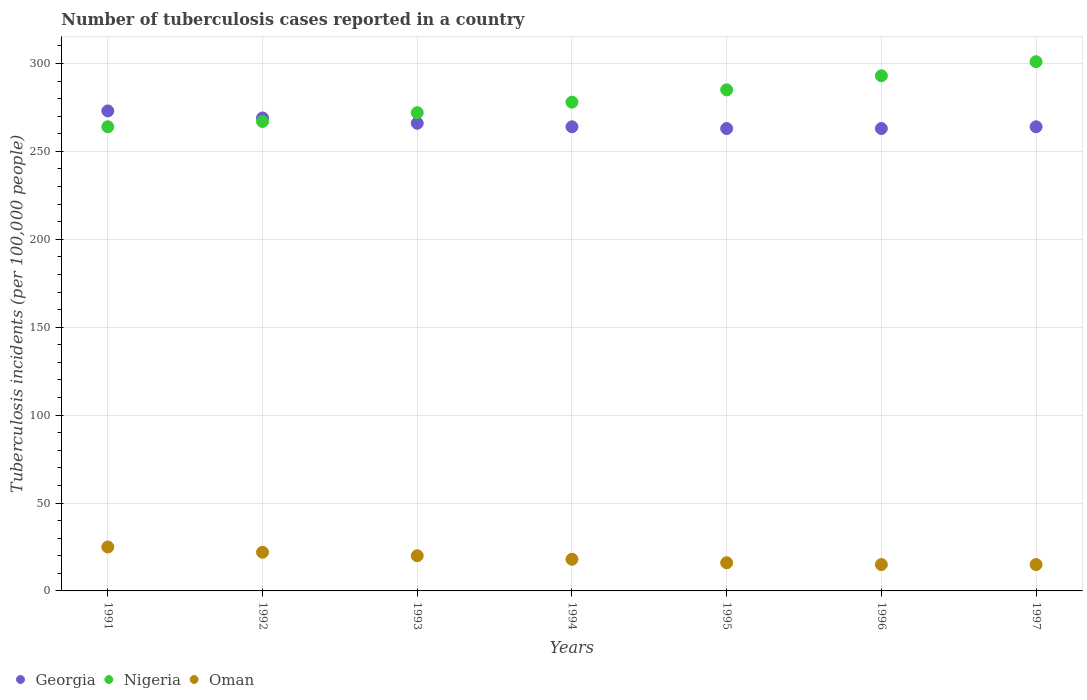How many different coloured dotlines are there?
Your answer should be very brief. 3. Is the number of dotlines equal to the number of legend labels?
Ensure brevity in your answer.  Yes. What is the number of tuberculosis cases reported in in Nigeria in 1996?
Your answer should be very brief. 293. Across all years, what is the maximum number of tuberculosis cases reported in in Georgia?
Provide a short and direct response. 273. Across all years, what is the minimum number of tuberculosis cases reported in in Nigeria?
Provide a short and direct response. 264. In which year was the number of tuberculosis cases reported in in Nigeria maximum?
Give a very brief answer. 1997. In which year was the number of tuberculosis cases reported in in Georgia minimum?
Make the answer very short. 1995. What is the total number of tuberculosis cases reported in in Georgia in the graph?
Provide a succinct answer. 1862. What is the difference between the number of tuberculosis cases reported in in Nigeria in 1994 and that in 1997?
Your answer should be compact. -23. What is the difference between the number of tuberculosis cases reported in in Oman in 1994 and the number of tuberculosis cases reported in in Nigeria in 1997?
Make the answer very short. -283. What is the average number of tuberculosis cases reported in in Nigeria per year?
Your answer should be compact. 280. In the year 1992, what is the difference between the number of tuberculosis cases reported in in Oman and number of tuberculosis cases reported in in Georgia?
Provide a succinct answer. -247. What is the ratio of the number of tuberculosis cases reported in in Nigeria in 1991 to that in 1993?
Give a very brief answer. 0.97. What is the difference between the highest and the lowest number of tuberculosis cases reported in in Oman?
Offer a terse response. 10. In how many years, is the number of tuberculosis cases reported in in Oman greater than the average number of tuberculosis cases reported in in Oman taken over all years?
Provide a succinct answer. 3. Is the sum of the number of tuberculosis cases reported in in Nigeria in 1993 and 1995 greater than the maximum number of tuberculosis cases reported in in Oman across all years?
Give a very brief answer. Yes. Does the number of tuberculosis cases reported in in Nigeria monotonically increase over the years?
Your answer should be compact. Yes. Is the number of tuberculosis cases reported in in Nigeria strictly greater than the number of tuberculosis cases reported in in Oman over the years?
Your answer should be very brief. Yes. How many dotlines are there?
Your response must be concise. 3. Does the graph contain any zero values?
Offer a terse response. No. Does the graph contain grids?
Keep it short and to the point. Yes. Where does the legend appear in the graph?
Offer a very short reply. Bottom left. How many legend labels are there?
Give a very brief answer. 3. What is the title of the graph?
Keep it short and to the point. Number of tuberculosis cases reported in a country. Does "Niger" appear as one of the legend labels in the graph?
Your answer should be compact. No. What is the label or title of the X-axis?
Offer a very short reply. Years. What is the label or title of the Y-axis?
Ensure brevity in your answer.  Tuberculosis incidents (per 100,0 people). What is the Tuberculosis incidents (per 100,000 people) of Georgia in 1991?
Offer a very short reply. 273. What is the Tuberculosis incidents (per 100,000 people) in Nigeria in 1991?
Your response must be concise. 264. What is the Tuberculosis incidents (per 100,000 people) of Oman in 1991?
Ensure brevity in your answer.  25. What is the Tuberculosis incidents (per 100,000 people) in Georgia in 1992?
Give a very brief answer. 269. What is the Tuberculosis incidents (per 100,000 people) in Nigeria in 1992?
Offer a very short reply. 267. What is the Tuberculosis incidents (per 100,000 people) in Oman in 1992?
Ensure brevity in your answer.  22. What is the Tuberculosis incidents (per 100,000 people) in Georgia in 1993?
Ensure brevity in your answer.  266. What is the Tuberculosis incidents (per 100,000 people) of Nigeria in 1993?
Provide a succinct answer. 272. What is the Tuberculosis incidents (per 100,000 people) of Georgia in 1994?
Your response must be concise. 264. What is the Tuberculosis incidents (per 100,000 people) in Nigeria in 1994?
Offer a very short reply. 278. What is the Tuberculosis incidents (per 100,000 people) of Georgia in 1995?
Your answer should be compact. 263. What is the Tuberculosis incidents (per 100,000 people) of Nigeria in 1995?
Offer a terse response. 285. What is the Tuberculosis incidents (per 100,000 people) in Georgia in 1996?
Make the answer very short. 263. What is the Tuberculosis incidents (per 100,000 people) in Nigeria in 1996?
Keep it short and to the point. 293. What is the Tuberculosis incidents (per 100,000 people) in Oman in 1996?
Your response must be concise. 15. What is the Tuberculosis incidents (per 100,000 people) in Georgia in 1997?
Keep it short and to the point. 264. What is the Tuberculosis incidents (per 100,000 people) in Nigeria in 1997?
Ensure brevity in your answer.  301. Across all years, what is the maximum Tuberculosis incidents (per 100,000 people) of Georgia?
Your answer should be very brief. 273. Across all years, what is the maximum Tuberculosis incidents (per 100,000 people) in Nigeria?
Ensure brevity in your answer.  301. Across all years, what is the maximum Tuberculosis incidents (per 100,000 people) of Oman?
Your response must be concise. 25. Across all years, what is the minimum Tuberculosis incidents (per 100,000 people) of Georgia?
Your answer should be compact. 263. Across all years, what is the minimum Tuberculosis incidents (per 100,000 people) of Nigeria?
Make the answer very short. 264. Across all years, what is the minimum Tuberculosis incidents (per 100,000 people) of Oman?
Provide a succinct answer. 15. What is the total Tuberculosis incidents (per 100,000 people) in Georgia in the graph?
Give a very brief answer. 1862. What is the total Tuberculosis incidents (per 100,000 people) of Nigeria in the graph?
Make the answer very short. 1960. What is the total Tuberculosis incidents (per 100,000 people) in Oman in the graph?
Give a very brief answer. 131. What is the difference between the Tuberculosis incidents (per 100,000 people) of Georgia in 1991 and that in 1992?
Give a very brief answer. 4. What is the difference between the Tuberculosis incidents (per 100,000 people) in Nigeria in 1991 and that in 1992?
Offer a terse response. -3. What is the difference between the Tuberculosis incidents (per 100,000 people) of Oman in 1991 and that in 1992?
Make the answer very short. 3. What is the difference between the Tuberculosis incidents (per 100,000 people) of Georgia in 1991 and that in 1993?
Provide a short and direct response. 7. What is the difference between the Tuberculosis incidents (per 100,000 people) in Oman in 1991 and that in 1993?
Offer a very short reply. 5. What is the difference between the Tuberculosis incidents (per 100,000 people) of Oman in 1991 and that in 1994?
Make the answer very short. 7. What is the difference between the Tuberculosis incidents (per 100,000 people) of Georgia in 1991 and that in 1996?
Provide a succinct answer. 10. What is the difference between the Tuberculosis incidents (per 100,000 people) of Nigeria in 1991 and that in 1996?
Ensure brevity in your answer.  -29. What is the difference between the Tuberculosis incidents (per 100,000 people) of Georgia in 1991 and that in 1997?
Offer a terse response. 9. What is the difference between the Tuberculosis incidents (per 100,000 people) of Nigeria in 1991 and that in 1997?
Your response must be concise. -37. What is the difference between the Tuberculosis incidents (per 100,000 people) of Nigeria in 1992 and that in 1993?
Your answer should be very brief. -5. What is the difference between the Tuberculosis incidents (per 100,000 people) in Oman in 1992 and that in 1993?
Provide a short and direct response. 2. What is the difference between the Tuberculosis incidents (per 100,000 people) in Georgia in 1992 and that in 1994?
Provide a short and direct response. 5. What is the difference between the Tuberculosis incidents (per 100,000 people) of Nigeria in 1992 and that in 1994?
Keep it short and to the point. -11. What is the difference between the Tuberculosis incidents (per 100,000 people) in Oman in 1992 and that in 1994?
Ensure brevity in your answer.  4. What is the difference between the Tuberculosis incidents (per 100,000 people) in Nigeria in 1992 and that in 1995?
Give a very brief answer. -18. What is the difference between the Tuberculosis incidents (per 100,000 people) of Oman in 1992 and that in 1996?
Provide a short and direct response. 7. What is the difference between the Tuberculosis incidents (per 100,000 people) in Nigeria in 1992 and that in 1997?
Your response must be concise. -34. What is the difference between the Tuberculosis incidents (per 100,000 people) in Oman in 1992 and that in 1997?
Keep it short and to the point. 7. What is the difference between the Tuberculosis incidents (per 100,000 people) of Nigeria in 1993 and that in 1994?
Your response must be concise. -6. What is the difference between the Tuberculosis incidents (per 100,000 people) in Oman in 1993 and that in 1994?
Make the answer very short. 2. What is the difference between the Tuberculosis incidents (per 100,000 people) of Oman in 1993 and that in 1995?
Provide a short and direct response. 4. What is the difference between the Tuberculosis incidents (per 100,000 people) in Georgia in 1993 and that in 1996?
Your response must be concise. 3. What is the difference between the Tuberculosis incidents (per 100,000 people) of Nigeria in 1993 and that in 1996?
Keep it short and to the point. -21. What is the difference between the Tuberculosis incidents (per 100,000 people) of Oman in 1993 and that in 1996?
Keep it short and to the point. 5. What is the difference between the Tuberculosis incidents (per 100,000 people) of Georgia in 1993 and that in 1997?
Provide a succinct answer. 2. What is the difference between the Tuberculosis incidents (per 100,000 people) of Georgia in 1994 and that in 1995?
Keep it short and to the point. 1. What is the difference between the Tuberculosis incidents (per 100,000 people) in Nigeria in 1994 and that in 1995?
Provide a succinct answer. -7. What is the difference between the Tuberculosis incidents (per 100,000 people) in Georgia in 1994 and that in 1996?
Make the answer very short. 1. What is the difference between the Tuberculosis incidents (per 100,000 people) in Nigeria in 1994 and that in 1996?
Offer a very short reply. -15. What is the difference between the Tuberculosis incidents (per 100,000 people) in Georgia in 1994 and that in 1997?
Make the answer very short. 0. What is the difference between the Tuberculosis incidents (per 100,000 people) in Oman in 1994 and that in 1997?
Ensure brevity in your answer.  3. What is the difference between the Tuberculosis incidents (per 100,000 people) of Georgia in 1996 and that in 1997?
Make the answer very short. -1. What is the difference between the Tuberculosis incidents (per 100,000 people) of Georgia in 1991 and the Tuberculosis incidents (per 100,000 people) of Nigeria in 1992?
Your answer should be compact. 6. What is the difference between the Tuberculosis incidents (per 100,000 people) in Georgia in 1991 and the Tuberculosis incidents (per 100,000 people) in Oman in 1992?
Provide a succinct answer. 251. What is the difference between the Tuberculosis incidents (per 100,000 people) in Nigeria in 1991 and the Tuberculosis incidents (per 100,000 people) in Oman in 1992?
Your answer should be compact. 242. What is the difference between the Tuberculosis incidents (per 100,000 people) in Georgia in 1991 and the Tuberculosis incidents (per 100,000 people) in Nigeria in 1993?
Provide a succinct answer. 1. What is the difference between the Tuberculosis incidents (per 100,000 people) in Georgia in 1991 and the Tuberculosis incidents (per 100,000 people) in Oman in 1993?
Make the answer very short. 253. What is the difference between the Tuberculosis incidents (per 100,000 people) of Nigeria in 1991 and the Tuberculosis incidents (per 100,000 people) of Oman in 1993?
Your answer should be very brief. 244. What is the difference between the Tuberculosis incidents (per 100,000 people) of Georgia in 1991 and the Tuberculosis incidents (per 100,000 people) of Oman in 1994?
Offer a very short reply. 255. What is the difference between the Tuberculosis incidents (per 100,000 people) in Nigeria in 1991 and the Tuberculosis incidents (per 100,000 people) in Oman in 1994?
Keep it short and to the point. 246. What is the difference between the Tuberculosis incidents (per 100,000 people) in Georgia in 1991 and the Tuberculosis incidents (per 100,000 people) in Nigeria in 1995?
Keep it short and to the point. -12. What is the difference between the Tuberculosis incidents (per 100,000 people) in Georgia in 1991 and the Tuberculosis incidents (per 100,000 people) in Oman in 1995?
Offer a very short reply. 257. What is the difference between the Tuberculosis incidents (per 100,000 people) in Nigeria in 1991 and the Tuberculosis incidents (per 100,000 people) in Oman in 1995?
Offer a terse response. 248. What is the difference between the Tuberculosis incidents (per 100,000 people) in Georgia in 1991 and the Tuberculosis incidents (per 100,000 people) in Oman in 1996?
Your answer should be very brief. 258. What is the difference between the Tuberculosis incidents (per 100,000 people) in Nigeria in 1991 and the Tuberculosis incidents (per 100,000 people) in Oman in 1996?
Offer a very short reply. 249. What is the difference between the Tuberculosis incidents (per 100,000 people) of Georgia in 1991 and the Tuberculosis incidents (per 100,000 people) of Nigeria in 1997?
Give a very brief answer. -28. What is the difference between the Tuberculosis incidents (per 100,000 people) of Georgia in 1991 and the Tuberculosis incidents (per 100,000 people) of Oman in 1997?
Keep it short and to the point. 258. What is the difference between the Tuberculosis incidents (per 100,000 people) of Nigeria in 1991 and the Tuberculosis incidents (per 100,000 people) of Oman in 1997?
Make the answer very short. 249. What is the difference between the Tuberculosis incidents (per 100,000 people) in Georgia in 1992 and the Tuberculosis incidents (per 100,000 people) in Oman in 1993?
Provide a short and direct response. 249. What is the difference between the Tuberculosis incidents (per 100,000 people) of Nigeria in 1992 and the Tuberculosis incidents (per 100,000 people) of Oman in 1993?
Make the answer very short. 247. What is the difference between the Tuberculosis incidents (per 100,000 people) in Georgia in 1992 and the Tuberculosis incidents (per 100,000 people) in Oman in 1994?
Ensure brevity in your answer.  251. What is the difference between the Tuberculosis incidents (per 100,000 people) of Nigeria in 1992 and the Tuberculosis incidents (per 100,000 people) of Oman in 1994?
Offer a terse response. 249. What is the difference between the Tuberculosis incidents (per 100,000 people) of Georgia in 1992 and the Tuberculosis incidents (per 100,000 people) of Nigeria in 1995?
Your response must be concise. -16. What is the difference between the Tuberculosis incidents (per 100,000 people) in Georgia in 1992 and the Tuberculosis incidents (per 100,000 people) in Oman in 1995?
Ensure brevity in your answer.  253. What is the difference between the Tuberculosis incidents (per 100,000 people) of Nigeria in 1992 and the Tuberculosis incidents (per 100,000 people) of Oman in 1995?
Offer a very short reply. 251. What is the difference between the Tuberculosis incidents (per 100,000 people) of Georgia in 1992 and the Tuberculosis incidents (per 100,000 people) of Oman in 1996?
Make the answer very short. 254. What is the difference between the Tuberculosis incidents (per 100,000 people) of Nigeria in 1992 and the Tuberculosis incidents (per 100,000 people) of Oman in 1996?
Provide a succinct answer. 252. What is the difference between the Tuberculosis incidents (per 100,000 people) of Georgia in 1992 and the Tuberculosis incidents (per 100,000 people) of Nigeria in 1997?
Give a very brief answer. -32. What is the difference between the Tuberculosis incidents (per 100,000 people) of Georgia in 1992 and the Tuberculosis incidents (per 100,000 people) of Oman in 1997?
Give a very brief answer. 254. What is the difference between the Tuberculosis incidents (per 100,000 people) in Nigeria in 1992 and the Tuberculosis incidents (per 100,000 people) in Oman in 1997?
Ensure brevity in your answer.  252. What is the difference between the Tuberculosis incidents (per 100,000 people) of Georgia in 1993 and the Tuberculosis incidents (per 100,000 people) of Oman in 1994?
Provide a succinct answer. 248. What is the difference between the Tuberculosis incidents (per 100,000 people) of Nigeria in 1993 and the Tuberculosis incidents (per 100,000 people) of Oman in 1994?
Provide a short and direct response. 254. What is the difference between the Tuberculosis incidents (per 100,000 people) in Georgia in 1993 and the Tuberculosis incidents (per 100,000 people) in Oman in 1995?
Make the answer very short. 250. What is the difference between the Tuberculosis incidents (per 100,000 people) in Nigeria in 1993 and the Tuberculosis incidents (per 100,000 people) in Oman in 1995?
Ensure brevity in your answer.  256. What is the difference between the Tuberculosis incidents (per 100,000 people) of Georgia in 1993 and the Tuberculosis incidents (per 100,000 people) of Oman in 1996?
Your answer should be compact. 251. What is the difference between the Tuberculosis incidents (per 100,000 people) in Nigeria in 1993 and the Tuberculosis incidents (per 100,000 people) in Oman in 1996?
Make the answer very short. 257. What is the difference between the Tuberculosis incidents (per 100,000 people) of Georgia in 1993 and the Tuberculosis incidents (per 100,000 people) of Nigeria in 1997?
Your answer should be compact. -35. What is the difference between the Tuberculosis incidents (per 100,000 people) of Georgia in 1993 and the Tuberculosis incidents (per 100,000 people) of Oman in 1997?
Provide a short and direct response. 251. What is the difference between the Tuberculosis incidents (per 100,000 people) of Nigeria in 1993 and the Tuberculosis incidents (per 100,000 people) of Oman in 1997?
Your answer should be very brief. 257. What is the difference between the Tuberculosis incidents (per 100,000 people) in Georgia in 1994 and the Tuberculosis incidents (per 100,000 people) in Nigeria in 1995?
Your answer should be compact. -21. What is the difference between the Tuberculosis incidents (per 100,000 people) in Georgia in 1994 and the Tuberculosis incidents (per 100,000 people) in Oman in 1995?
Provide a succinct answer. 248. What is the difference between the Tuberculosis incidents (per 100,000 people) in Nigeria in 1994 and the Tuberculosis incidents (per 100,000 people) in Oman in 1995?
Provide a succinct answer. 262. What is the difference between the Tuberculosis incidents (per 100,000 people) of Georgia in 1994 and the Tuberculosis incidents (per 100,000 people) of Nigeria in 1996?
Provide a short and direct response. -29. What is the difference between the Tuberculosis incidents (per 100,000 people) of Georgia in 1994 and the Tuberculosis incidents (per 100,000 people) of Oman in 1996?
Provide a succinct answer. 249. What is the difference between the Tuberculosis incidents (per 100,000 people) in Nigeria in 1994 and the Tuberculosis incidents (per 100,000 people) in Oman in 1996?
Offer a terse response. 263. What is the difference between the Tuberculosis incidents (per 100,000 people) in Georgia in 1994 and the Tuberculosis incidents (per 100,000 people) in Nigeria in 1997?
Make the answer very short. -37. What is the difference between the Tuberculosis incidents (per 100,000 people) in Georgia in 1994 and the Tuberculosis incidents (per 100,000 people) in Oman in 1997?
Your answer should be compact. 249. What is the difference between the Tuberculosis incidents (per 100,000 people) of Nigeria in 1994 and the Tuberculosis incidents (per 100,000 people) of Oman in 1997?
Ensure brevity in your answer.  263. What is the difference between the Tuberculosis incidents (per 100,000 people) in Georgia in 1995 and the Tuberculosis incidents (per 100,000 people) in Nigeria in 1996?
Your response must be concise. -30. What is the difference between the Tuberculosis incidents (per 100,000 people) in Georgia in 1995 and the Tuberculosis incidents (per 100,000 people) in Oman in 1996?
Your answer should be very brief. 248. What is the difference between the Tuberculosis incidents (per 100,000 people) in Nigeria in 1995 and the Tuberculosis incidents (per 100,000 people) in Oman in 1996?
Offer a terse response. 270. What is the difference between the Tuberculosis incidents (per 100,000 people) of Georgia in 1995 and the Tuberculosis incidents (per 100,000 people) of Nigeria in 1997?
Keep it short and to the point. -38. What is the difference between the Tuberculosis incidents (per 100,000 people) in Georgia in 1995 and the Tuberculosis incidents (per 100,000 people) in Oman in 1997?
Offer a terse response. 248. What is the difference between the Tuberculosis incidents (per 100,000 people) in Nigeria in 1995 and the Tuberculosis incidents (per 100,000 people) in Oman in 1997?
Make the answer very short. 270. What is the difference between the Tuberculosis incidents (per 100,000 people) in Georgia in 1996 and the Tuberculosis incidents (per 100,000 people) in Nigeria in 1997?
Ensure brevity in your answer.  -38. What is the difference between the Tuberculosis incidents (per 100,000 people) in Georgia in 1996 and the Tuberculosis incidents (per 100,000 people) in Oman in 1997?
Offer a terse response. 248. What is the difference between the Tuberculosis incidents (per 100,000 people) in Nigeria in 1996 and the Tuberculosis incidents (per 100,000 people) in Oman in 1997?
Offer a very short reply. 278. What is the average Tuberculosis incidents (per 100,000 people) of Georgia per year?
Keep it short and to the point. 266. What is the average Tuberculosis incidents (per 100,000 people) in Nigeria per year?
Your answer should be compact. 280. What is the average Tuberculosis incidents (per 100,000 people) of Oman per year?
Your response must be concise. 18.71. In the year 1991, what is the difference between the Tuberculosis incidents (per 100,000 people) of Georgia and Tuberculosis incidents (per 100,000 people) of Oman?
Ensure brevity in your answer.  248. In the year 1991, what is the difference between the Tuberculosis incidents (per 100,000 people) in Nigeria and Tuberculosis incidents (per 100,000 people) in Oman?
Your answer should be compact. 239. In the year 1992, what is the difference between the Tuberculosis incidents (per 100,000 people) of Georgia and Tuberculosis incidents (per 100,000 people) of Nigeria?
Offer a terse response. 2. In the year 1992, what is the difference between the Tuberculosis incidents (per 100,000 people) in Georgia and Tuberculosis incidents (per 100,000 people) in Oman?
Give a very brief answer. 247. In the year 1992, what is the difference between the Tuberculosis incidents (per 100,000 people) of Nigeria and Tuberculosis incidents (per 100,000 people) of Oman?
Offer a very short reply. 245. In the year 1993, what is the difference between the Tuberculosis incidents (per 100,000 people) in Georgia and Tuberculosis incidents (per 100,000 people) in Oman?
Provide a succinct answer. 246. In the year 1993, what is the difference between the Tuberculosis incidents (per 100,000 people) in Nigeria and Tuberculosis incidents (per 100,000 people) in Oman?
Your answer should be compact. 252. In the year 1994, what is the difference between the Tuberculosis incidents (per 100,000 people) in Georgia and Tuberculosis incidents (per 100,000 people) in Oman?
Offer a very short reply. 246. In the year 1994, what is the difference between the Tuberculosis incidents (per 100,000 people) of Nigeria and Tuberculosis incidents (per 100,000 people) of Oman?
Offer a very short reply. 260. In the year 1995, what is the difference between the Tuberculosis incidents (per 100,000 people) of Georgia and Tuberculosis incidents (per 100,000 people) of Nigeria?
Your answer should be compact. -22. In the year 1995, what is the difference between the Tuberculosis incidents (per 100,000 people) of Georgia and Tuberculosis incidents (per 100,000 people) of Oman?
Keep it short and to the point. 247. In the year 1995, what is the difference between the Tuberculosis incidents (per 100,000 people) of Nigeria and Tuberculosis incidents (per 100,000 people) of Oman?
Your answer should be compact. 269. In the year 1996, what is the difference between the Tuberculosis incidents (per 100,000 people) in Georgia and Tuberculosis incidents (per 100,000 people) in Oman?
Keep it short and to the point. 248. In the year 1996, what is the difference between the Tuberculosis incidents (per 100,000 people) in Nigeria and Tuberculosis incidents (per 100,000 people) in Oman?
Give a very brief answer. 278. In the year 1997, what is the difference between the Tuberculosis incidents (per 100,000 people) of Georgia and Tuberculosis incidents (per 100,000 people) of Nigeria?
Offer a very short reply. -37. In the year 1997, what is the difference between the Tuberculosis incidents (per 100,000 people) of Georgia and Tuberculosis incidents (per 100,000 people) of Oman?
Provide a short and direct response. 249. In the year 1997, what is the difference between the Tuberculosis incidents (per 100,000 people) of Nigeria and Tuberculosis incidents (per 100,000 people) of Oman?
Give a very brief answer. 286. What is the ratio of the Tuberculosis incidents (per 100,000 people) of Georgia in 1991 to that in 1992?
Your response must be concise. 1.01. What is the ratio of the Tuberculosis incidents (per 100,000 people) in Nigeria in 1991 to that in 1992?
Your answer should be compact. 0.99. What is the ratio of the Tuberculosis incidents (per 100,000 people) of Oman in 1991 to that in 1992?
Keep it short and to the point. 1.14. What is the ratio of the Tuberculosis incidents (per 100,000 people) of Georgia in 1991 to that in 1993?
Your response must be concise. 1.03. What is the ratio of the Tuberculosis incidents (per 100,000 people) of Nigeria in 1991 to that in 1993?
Provide a succinct answer. 0.97. What is the ratio of the Tuberculosis incidents (per 100,000 people) in Georgia in 1991 to that in 1994?
Give a very brief answer. 1.03. What is the ratio of the Tuberculosis incidents (per 100,000 people) in Nigeria in 1991 to that in 1994?
Give a very brief answer. 0.95. What is the ratio of the Tuberculosis incidents (per 100,000 people) of Oman in 1991 to that in 1994?
Ensure brevity in your answer.  1.39. What is the ratio of the Tuberculosis incidents (per 100,000 people) in Georgia in 1991 to that in 1995?
Offer a very short reply. 1.04. What is the ratio of the Tuberculosis incidents (per 100,000 people) in Nigeria in 1991 to that in 1995?
Provide a short and direct response. 0.93. What is the ratio of the Tuberculosis incidents (per 100,000 people) in Oman in 1991 to that in 1995?
Offer a very short reply. 1.56. What is the ratio of the Tuberculosis incidents (per 100,000 people) of Georgia in 1991 to that in 1996?
Offer a terse response. 1.04. What is the ratio of the Tuberculosis incidents (per 100,000 people) of Nigeria in 1991 to that in 1996?
Give a very brief answer. 0.9. What is the ratio of the Tuberculosis incidents (per 100,000 people) of Oman in 1991 to that in 1996?
Provide a short and direct response. 1.67. What is the ratio of the Tuberculosis incidents (per 100,000 people) of Georgia in 1991 to that in 1997?
Your answer should be very brief. 1.03. What is the ratio of the Tuberculosis incidents (per 100,000 people) of Nigeria in 1991 to that in 1997?
Make the answer very short. 0.88. What is the ratio of the Tuberculosis incidents (per 100,000 people) of Oman in 1991 to that in 1997?
Offer a very short reply. 1.67. What is the ratio of the Tuberculosis incidents (per 100,000 people) in Georgia in 1992 to that in 1993?
Offer a terse response. 1.01. What is the ratio of the Tuberculosis incidents (per 100,000 people) in Nigeria in 1992 to that in 1993?
Provide a short and direct response. 0.98. What is the ratio of the Tuberculosis incidents (per 100,000 people) of Oman in 1992 to that in 1993?
Provide a succinct answer. 1.1. What is the ratio of the Tuberculosis incidents (per 100,000 people) in Georgia in 1992 to that in 1994?
Give a very brief answer. 1.02. What is the ratio of the Tuberculosis incidents (per 100,000 people) in Nigeria in 1992 to that in 1994?
Your answer should be compact. 0.96. What is the ratio of the Tuberculosis incidents (per 100,000 people) in Oman in 1992 to that in 1994?
Ensure brevity in your answer.  1.22. What is the ratio of the Tuberculosis incidents (per 100,000 people) of Georgia in 1992 to that in 1995?
Offer a terse response. 1.02. What is the ratio of the Tuberculosis incidents (per 100,000 people) of Nigeria in 1992 to that in 1995?
Offer a very short reply. 0.94. What is the ratio of the Tuberculosis incidents (per 100,000 people) of Oman in 1992 to that in 1995?
Your answer should be very brief. 1.38. What is the ratio of the Tuberculosis incidents (per 100,000 people) in Georgia in 1992 to that in 1996?
Give a very brief answer. 1.02. What is the ratio of the Tuberculosis incidents (per 100,000 people) of Nigeria in 1992 to that in 1996?
Offer a very short reply. 0.91. What is the ratio of the Tuberculosis incidents (per 100,000 people) of Oman in 1992 to that in 1996?
Provide a succinct answer. 1.47. What is the ratio of the Tuberculosis incidents (per 100,000 people) of Georgia in 1992 to that in 1997?
Keep it short and to the point. 1.02. What is the ratio of the Tuberculosis incidents (per 100,000 people) in Nigeria in 1992 to that in 1997?
Offer a very short reply. 0.89. What is the ratio of the Tuberculosis incidents (per 100,000 people) of Oman in 1992 to that in 1997?
Offer a very short reply. 1.47. What is the ratio of the Tuberculosis incidents (per 100,000 people) of Georgia in 1993 to that in 1994?
Keep it short and to the point. 1.01. What is the ratio of the Tuberculosis incidents (per 100,000 people) in Nigeria in 1993 to that in 1994?
Provide a short and direct response. 0.98. What is the ratio of the Tuberculosis incidents (per 100,000 people) of Georgia in 1993 to that in 1995?
Provide a short and direct response. 1.01. What is the ratio of the Tuberculosis incidents (per 100,000 people) in Nigeria in 1993 to that in 1995?
Your answer should be compact. 0.95. What is the ratio of the Tuberculosis incidents (per 100,000 people) of Oman in 1993 to that in 1995?
Your response must be concise. 1.25. What is the ratio of the Tuberculosis incidents (per 100,000 people) in Georgia in 1993 to that in 1996?
Your answer should be compact. 1.01. What is the ratio of the Tuberculosis incidents (per 100,000 people) in Nigeria in 1993 to that in 1996?
Offer a very short reply. 0.93. What is the ratio of the Tuberculosis incidents (per 100,000 people) in Georgia in 1993 to that in 1997?
Provide a short and direct response. 1.01. What is the ratio of the Tuberculosis incidents (per 100,000 people) of Nigeria in 1993 to that in 1997?
Provide a short and direct response. 0.9. What is the ratio of the Tuberculosis incidents (per 100,000 people) in Oman in 1993 to that in 1997?
Give a very brief answer. 1.33. What is the ratio of the Tuberculosis incidents (per 100,000 people) in Nigeria in 1994 to that in 1995?
Your answer should be compact. 0.98. What is the ratio of the Tuberculosis incidents (per 100,000 people) in Oman in 1994 to that in 1995?
Ensure brevity in your answer.  1.12. What is the ratio of the Tuberculosis incidents (per 100,000 people) in Nigeria in 1994 to that in 1996?
Your response must be concise. 0.95. What is the ratio of the Tuberculosis incidents (per 100,000 people) of Nigeria in 1994 to that in 1997?
Offer a terse response. 0.92. What is the ratio of the Tuberculosis incidents (per 100,000 people) of Nigeria in 1995 to that in 1996?
Ensure brevity in your answer.  0.97. What is the ratio of the Tuberculosis incidents (per 100,000 people) of Oman in 1995 to that in 1996?
Provide a succinct answer. 1.07. What is the ratio of the Tuberculosis incidents (per 100,000 people) in Nigeria in 1995 to that in 1997?
Give a very brief answer. 0.95. What is the ratio of the Tuberculosis incidents (per 100,000 people) in Oman in 1995 to that in 1997?
Keep it short and to the point. 1.07. What is the ratio of the Tuberculosis incidents (per 100,000 people) of Nigeria in 1996 to that in 1997?
Your response must be concise. 0.97. What is the difference between the highest and the second highest Tuberculosis incidents (per 100,000 people) of Nigeria?
Provide a short and direct response. 8. What is the difference between the highest and the second highest Tuberculosis incidents (per 100,000 people) of Oman?
Your response must be concise. 3. 